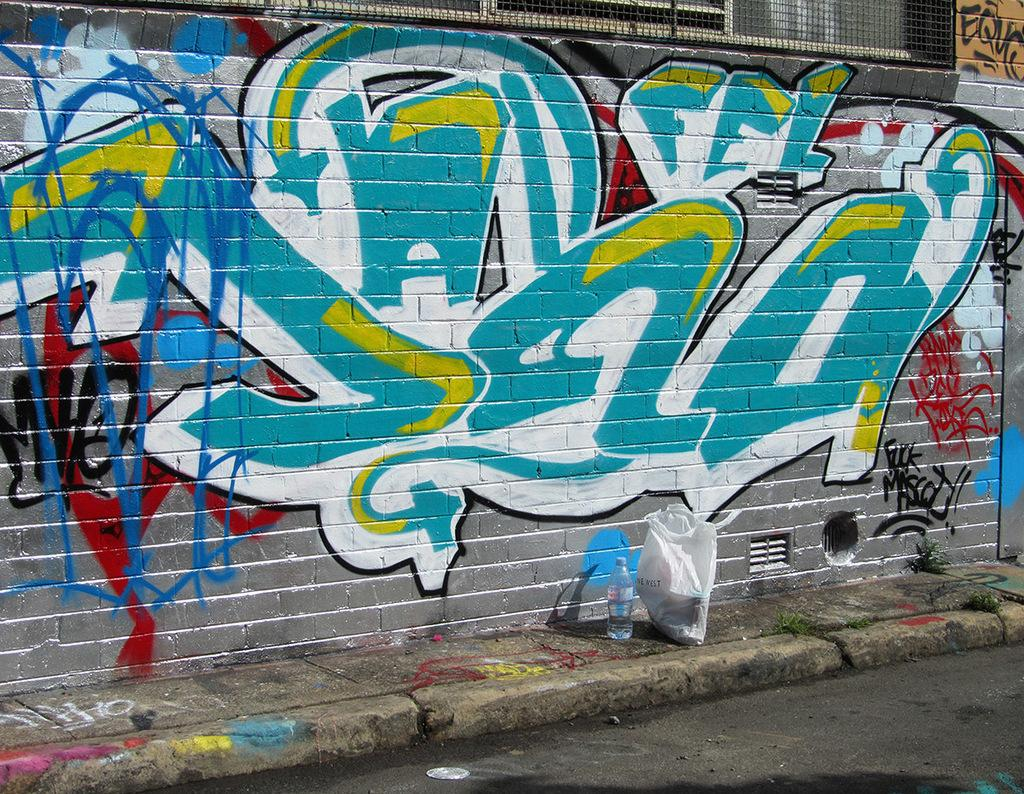What is present on the wall in the image? The wall has paint on it. What object can be seen covering something in the image? There is a cover in the image. What type of container is visible in the image? There is a bottle in the image. What type of surface is visible in the image? There is a road in the image. What type of living organism is present in the image? There is a plant in the image. Can you tell me how many grains of rice are present in the image? There is no rice present in the image. What type of animal is swimming in the image? There is no animal swimming in the image. 